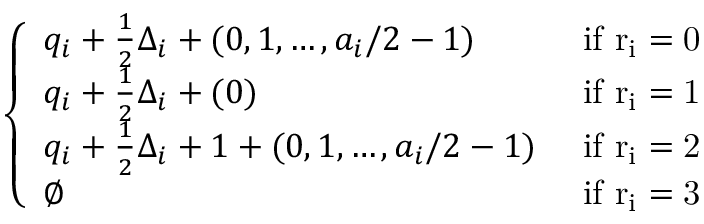Convert formula to latex. <formula><loc_0><loc_0><loc_500><loc_500>\left \{ \begin{array} { l l } { q _ { i } + \frac { 1 } { 2 } \Delta _ { i } + ( 0 , 1 , \dots , a _ { i } / 2 - 1 ) } & { i f r _ { i } = 0 } \\ { q _ { i } + \frac { 1 } { 2 } \Delta _ { i } + ( 0 ) } & { i f r _ { i } = 1 } \\ { q _ { i } + \frac { 1 } { 2 } \Delta _ { i } + 1 + ( 0 , 1 , \dots , a _ { i } / 2 - 1 ) } & { i f r _ { i } = 2 } \\ { \emptyset } & { i f r _ { i } = 3 } \end{array}</formula> 